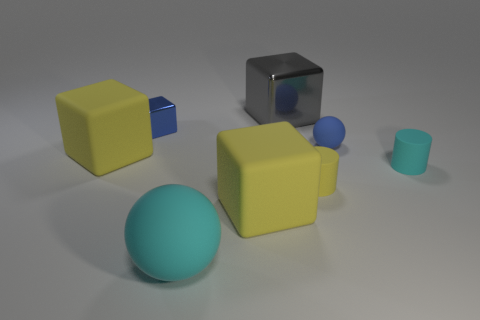Subtract all red balls. How many yellow cubes are left? 2 Subtract all small blue metal blocks. How many blocks are left? 3 Subtract 2 cubes. How many cubes are left? 2 Subtract all blue cubes. How many cubes are left? 3 Add 1 big cyan matte spheres. How many objects exist? 9 Subtract all cylinders. How many objects are left? 6 Subtract all purple cubes. Subtract all gray cylinders. How many cubes are left? 4 Subtract 0 red cylinders. How many objects are left? 8 Subtract all cylinders. Subtract all tiny yellow objects. How many objects are left? 5 Add 7 yellow cubes. How many yellow cubes are left? 9 